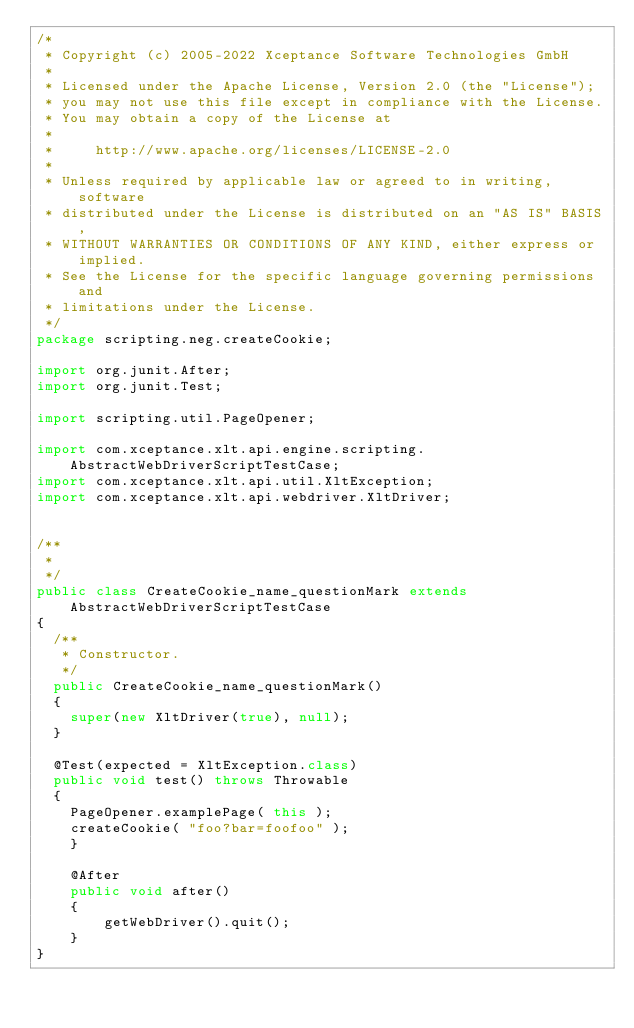<code> <loc_0><loc_0><loc_500><loc_500><_Java_>/*
 * Copyright (c) 2005-2022 Xceptance Software Technologies GmbH
 *
 * Licensed under the Apache License, Version 2.0 (the "License");
 * you may not use this file except in compliance with the License.
 * You may obtain a copy of the License at
 *
 *     http://www.apache.org/licenses/LICENSE-2.0
 *
 * Unless required by applicable law or agreed to in writing, software
 * distributed under the License is distributed on an "AS IS" BASIS,
 * WITHOUT WARRANTIES OR CONDITIONS OF ANY KIND, either express or implied.
 * See the License for the specific language governing permissions and
 * limitations under the License.
 */
package scripting.neg.createCookie;

import org.junit.After;
import org.junit.Test;

import scripting.util.PageOpener;

import com.xceptance.xlt.api.engine.scripting.AbstractWebDriverScriptTestCase;
import com.xceptance.xlt.api.util.XltException;
import com.xceptance.xlt.api.webdriver.XltDriver;


/**
 * 
 */
public class CreateCookie_name_questionMark extends AbstractWebDriverScriptTestCase
{
	/**
	 * Constructor.
	 */
	public CreateCookie_name_questionMark()
	{
		super(new XltDriver(true), null);
	}

	@Test(expected = XltException.class)
	public void test() throws Throwable
	{
		PageOpener.examplePage( this );
		createCookie( "foo?bar=foofoo" );
    }

    @After
    public void after()
    {
        getWebDriver().quit();
    }
}</code> 